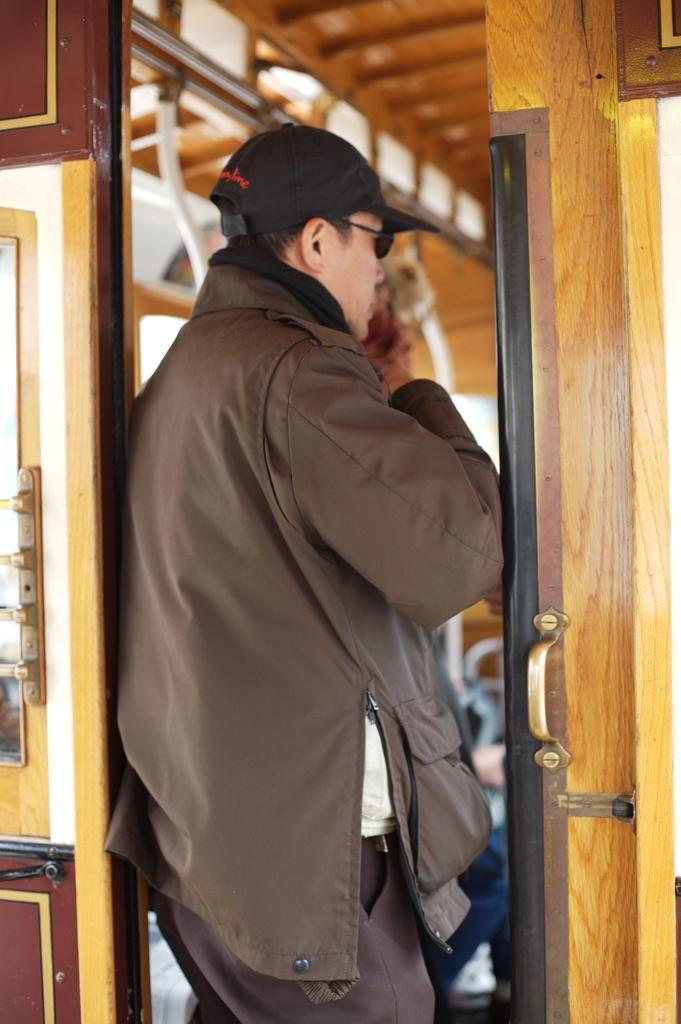Can you describe this image briefly? In this image we can see a person wearing goggles and a cap. Near to him there is a door with a handle. In the background it is blur. 